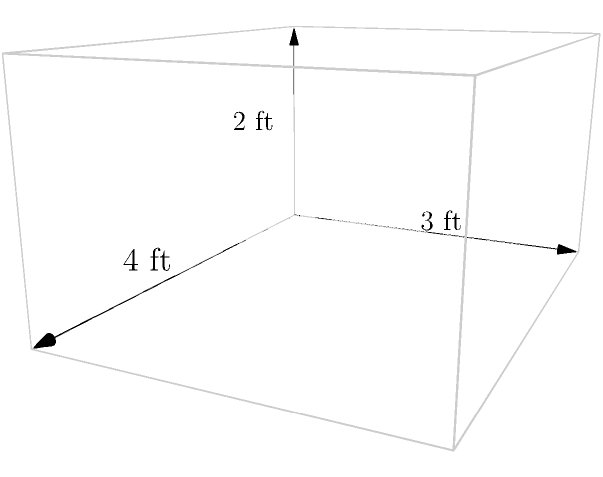You're designing a new display case for your retail shop in Boone Mall. The case is cuboid-shaped with dimensions 4 feet long, 3 feet wide, and 2 feet high. To determine the amount of glass needed, you need to calculate the total surface area of the case, excluding the bottom. What is the total surface area in square feet? Let's approach this step-by-step:

1) The display case is a cuboid with dimensions:
   Length (l) = 4 ft
   Width (w) = 3 ft
   Height (h) = 2 ft

2) We need to calculate the surface area of 5 sides (excluding the bottom):
   - Top (1 side): $l \times w$
   - Front and back (2 sides): $l \times h$ each
   - Left and right (2 sides): $w \times h$ each

3) Let's calculate each:
   - Top: $4 \times 3 = 12$ sq ft
   - Front and back: $2 \times (4 \times 2) = 16$ sq ft
   - Left and right: $2 \times (3 \times 2) = 12$ sq ft

4) Now, let's sum up all these areas:
   $$ \text{Total Surface Area} = 12 + 16 + 12 = 40 \text{ sq ft} $$

Therefore, the total surface area of the display case, excluding the bottom, is 40 square feet.
Answer: 40 sq ft 